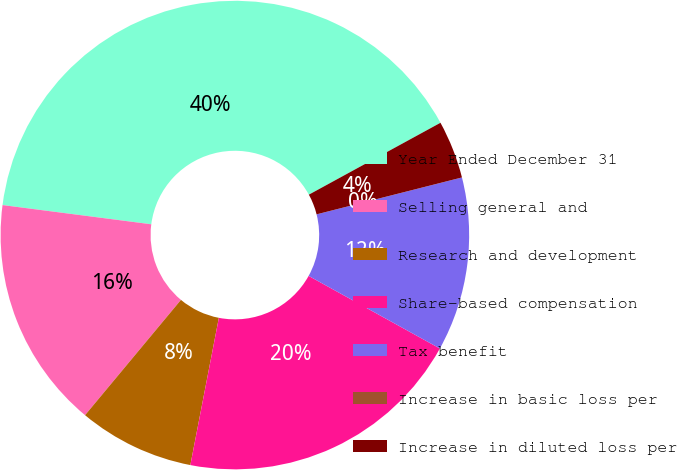<chart> <loc_0><loc_0><loc_500><loc_500><pie_chart><fcel>Year Ended December 31<fcel>Selling general and<fcel>Research and development<fcel>Share-based compensation<fcel>Tax benefit<fcel>Increase in basic loss per<fcel>Increase in diluted loss per<nl><fcel>40.0%<fcel>16.0%<fcel>8.0%<fcel>20.0%<fcel>12.0%<fcel>0.0%<fcel>4.0%<nl></chart> 